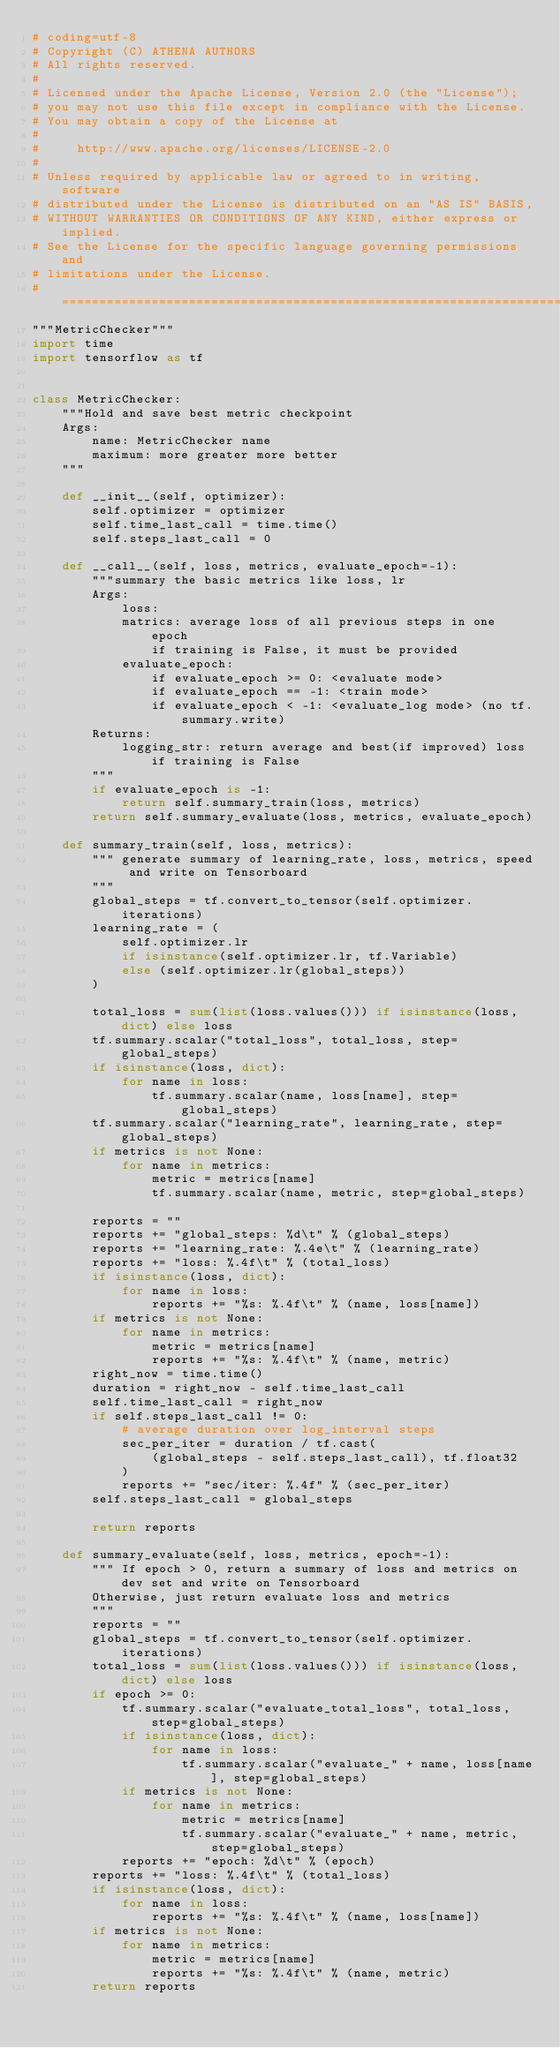<code> <loc_0><loc_0><loc_500><loc_500><_Python_># coding=utf-8
# Copyright (C) ATHENA AUTHORS
# All rights reserved.
#
# Licensed under the Apache License, Version 2.0 (the "License");
# you may not use this file except in compliance with the License.
# You may obtain a copy of the License at
#
#     http://www.apache.org/licenses/LICENSE-2.0
#
# Unless required by applicable law or agreed to in writing, software
# distributed under the License is distributed on an "AS IS" BASIS,
# WITHOUT WARRANTIES OR CONDITIONS OF ANY KIND, either express or implied.
# See the License for the specific language governing permissions and
# limitations under the License.
# ==============================================================================
"""MetricChecker"""
import time
import tensorflow as tf


class MetricChecker:
    """Hold and save best metric checkpoint
    Args:
        name: MetricChecker name
        maximum: more greater more better
    """

    def __init__(self, optimizer):
        self.optimizer = optimizer
        self.time_last_call = time.time()
        self.steps_last_call = 0

    def __call__(self, loss, metrics, evaluate_epoch=-1):
        """summary the basic metrics like loss, lr
        Args:
            loss:
            matrics: average loss of all previous steps in one epoch
                if training is False, it must be provided
            evaluate_epoch:
                if evaluate_epoch >= 0: <evaluate mode>
                if evaluate_epoch == -1: <train mode>
                if evaluate_epoch < -1: <evaluate_log mode> (no tf.summary.write)
        Returns:
            logging_str: return average and best(if improved) loss if training is False
        """
        if evaluate_epoch is -1:
            return self.summary_train(loss, metrics)
        return self.summary_evaluate(loss, metrics, evaluate_epoch)

    def summary_train(self, loss, metrics):
        """ generate summary of learning_rate, loss, metrics, speed and write on Tensorboard
        """
        global_steps = tf.convert_to_tensor(self.optimizer.iterations)
        learning_rate = (
            self.optimizer.lr
            if isinstance(self.optimizer.lr, tf.Variable)
            else (self.optimizer.lr(global_steps))
        )

        total_loss = sum(list(loss.values())) if isinstance(loss, dict) else loss
        tf.summary.scalar("total_loss", total_loss, step=global_steps)
        if isinstance(loss, dict):
            for name in loss:
                tf.summary.scalar(name, loss[name], step=global_steps)
        tf.summary.scalar("learning_rate", learning_rate, step=global_steps)
        if metrics is not None:
            for name in metrics:
                metric = metrics[name]
                tf.summary.scalar(name, metric, step=global_steps)

        reports = ""
        reports += "global_steps: %d\t" % (global_steps)
        reports += "learning_rate: %.4e\t" % (learning_rate)
        reports += "loss: %.4f\t" % (total_loss)
        if isinstance(loss, dict):
            for name in loss:
                reports += "%s: %.4f\t" % (name, loss[name])
        if metrics is not None:
            for name in metrics:
                metric = metrics[name]
                reports += "%s: %.4f\t" % (name, metric)
        right_now = time.time()
        duration = right_now - self.time_last_call
        self.time_last_call = right_now
        if self.steps_last_call != 0:
            # average duration over log_interval steps
            sec_per_iter = duration / tf.cast(
                (global_steps - self.steps_last_call), tf.float32
            )
            reports += "sec/iter: %.4f" % (sec_per_iter)
        self.steps_last_call = global_steps

        return reports

    def summary_evaluate(self, loss, metrics, epoch=-1):
        """ If epoch > 0, return a summary of loss and metrics on dev set and write on Tensorboard
        Otherwise, just return evaluate loss and metrics
        """
        reports = ""
        global_steps = tf.convert_to_tensor(self.optimizer.iterations)
        total_loss = sum(list(loss.values())) if isinstance(loss, dict) else loss
        if epoch >= 0:
            tf.summary.scalar("evaluate_total_loss", total_loss, step=global_steps)
            if isinstance(loss, dict):
                for name in loss:
                    tf.summary.scalar("evaluate_" + name, loss[name], step=global_steps)
            if metrics is not None:
                for name in metrics:
                    metric = metrics[name]
                    tf.summary.scalar("evaluate_" + name, metric, step=global_steps)
            reports += "epoch: %d\t" % (epoch)
        reports += "loss: %.4f\t" % (total_loss)
        if isinstance(loss, dict):
            for name in loss:
                reports += "%s: %.4f\t" % (name, loss[name])
        if metrics is not None:
            for name in metrics:
                metric = metrics[name]
                reports += "%s: %.4f\t" % (name, metric)
        return reports
</code> 